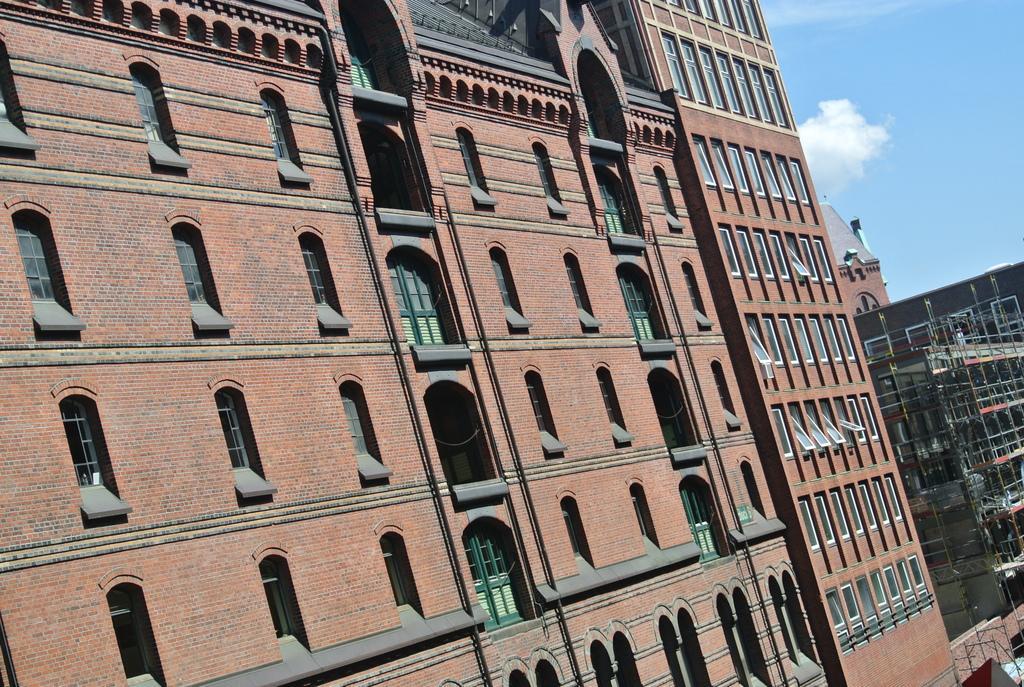In one or two sentences, can you explain what this image depicts? In this image there are buildings, and in the background there is sky. 